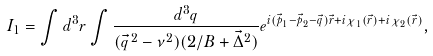Convert formula to latex. <formula><loc_0><loc_0><loc_500><loc_500>I _ { 1 } = \int d ^ { 3 } r \int \frac { d ^ { 3 } q } { ( \vec { q } ^ { \, 2 } - \nu ^ { 2 } ) ( 2 / B + \vec { \Delta } ^ { 2 } ) } e ^ { i ( \vec { p } _ { 1 } - \vec { p } _ { 2 } - \vec { q } ) \vec { r } + i \chi _ { 1 } ( \vec { r } ) + i \chi _ { 2 } ( \vec { r } ) } ,</formula> 